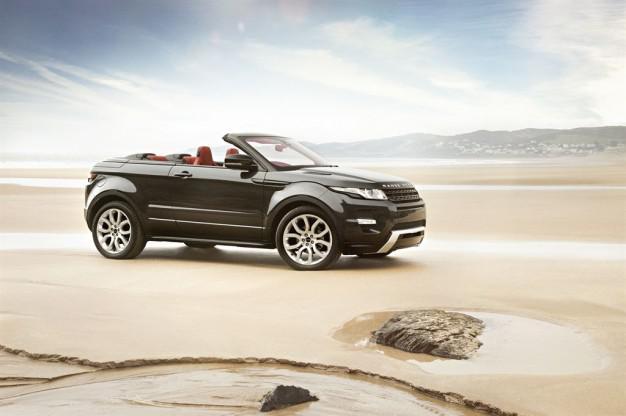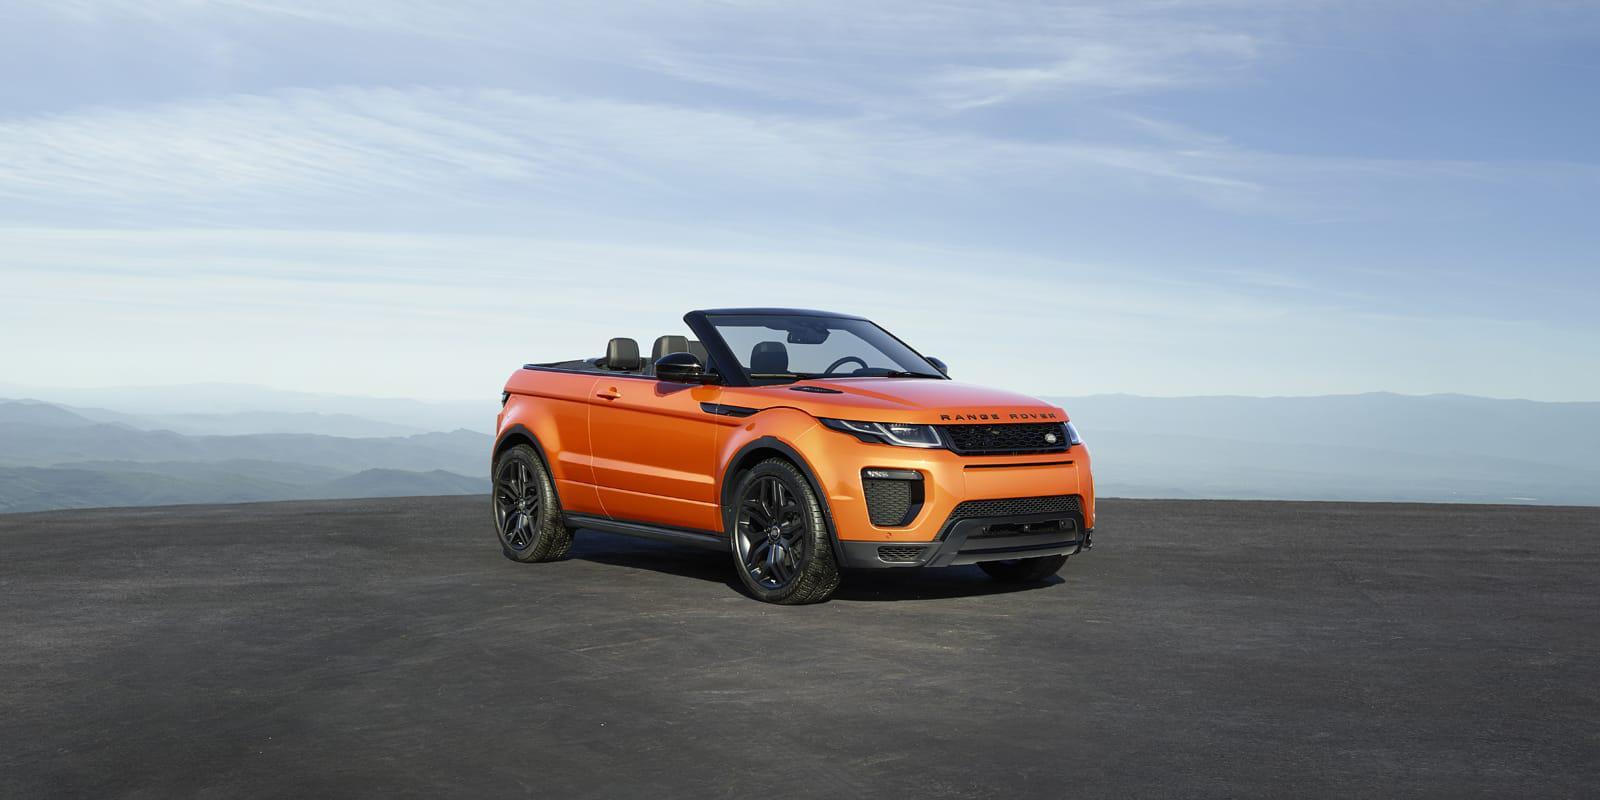The first image is the image on the left, the second image is the image on the right. For the images shown, is this caption "One of the images shows an orange vehicle." true? Answer yes or no. Yes. 